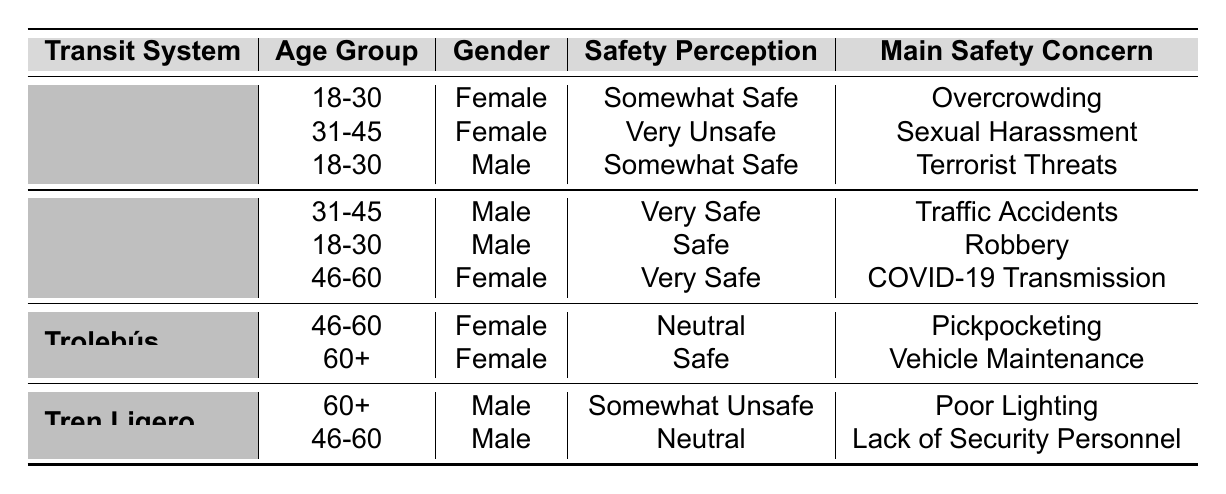What is the main safety concern for females aged 18-30 using the Metro? The table indicates that females aged 18-30 using the Metro cite "Overcrowding" as their main safety concern.
Answer: Overcrowding Which public transit system has the highest perceived safety rating among males aged 31-45? According to the table, Metrobús has the highest perceived safety rating ("Very Safe") among males aged 31-45.
Answer: Metrobús Are there any females aged 60+ who feel unsafe using public transit? Yes, according to the table, there is a male aged 60+ using Tren Ligero who feels "Somewhat Unsafe," but there are no females aged 60+ listed as feeling unsafe.
Answer: No What is the safety perception of male users aged 46-60 on Tren Ligero? The table shows that male users aged 46-60 perceive Tren Ligero as "Neutral."
Answer: Neutral How many different safety perceptions are recorded for the Metro? The table lists three different safety perceptions for the Metro: "Somewhat Safe," "Very Unsafe," and "Somewhat Safe." Summing these perceptions, the total is three distinct entries.
Answer: Three Is "Sexual Harassment" a main safety concern for any females using the Metro daily? Yes, the data indicates that a female in the 31-45 age group lists "Sexual Harassment" as her main safety concern while using the Metro daily.
Answer: Yes Compare the safety perceptions of the Trolebús users in the 46-60 and 60+ age groups. The 46-60 age group has a "Neutral" perception of safety, while the 60+ age group feels "Safe." The 60+ age group perceives safety more positively than the 46-60 group.
Answer: 60+ age group feels safer How many unique transit systems are mentioned in the table, and which one has the most negative safety perception? The table mentions four unique transit systems: Metro, Metrobús, Trolebús, and Tren Ligero. Among these, the Metro has the most negative safety perception ("Very Unsafe").
Answer: Four; Metro What is the primary safety concern for all transit systems combined according to the responses? By assessing the main safety concerns listed for all transit systems, the most frequently mentioned concerns include "Overcrowding," "Traffic Accidents," and "Sexual Harassment." However, "Overcrowding" appears solely in the Metro section, while others are represented multiple times.
Answer: Overcrowding Is it true that all females in the 18-30 age group feel safe using public transit? No, it is false. The table shows that a female in this age group using the Metro feels "Somewhat Safe," but not all females feel completely safe.
Answer: No 